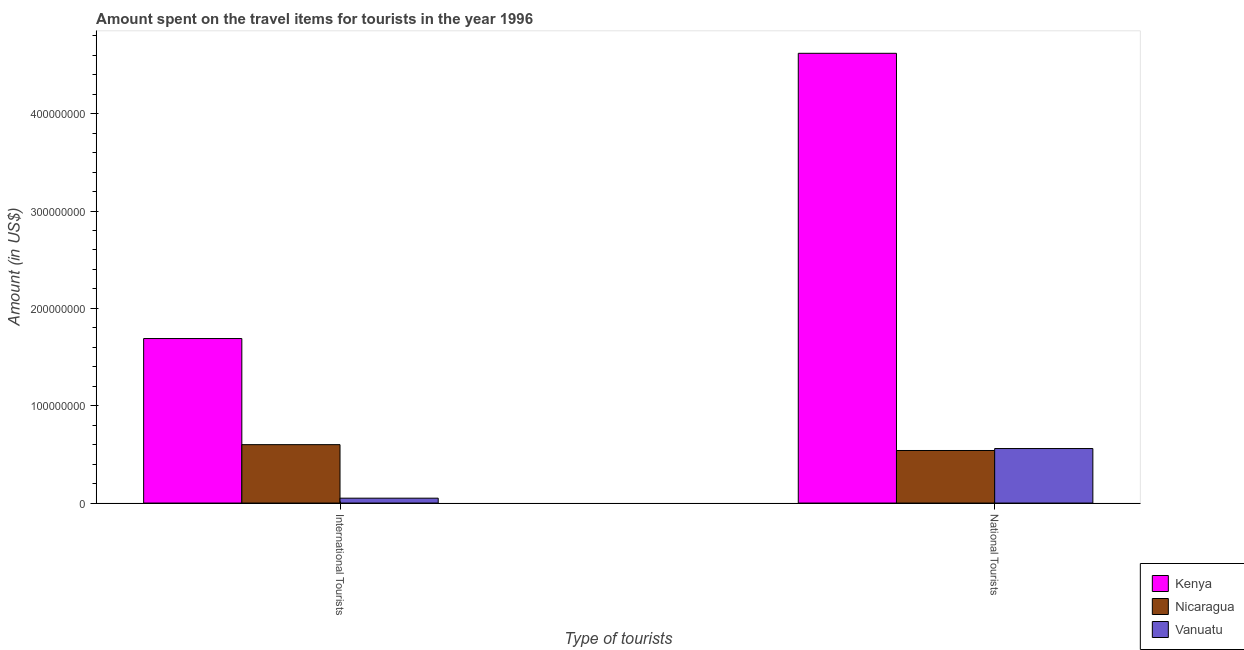How many groups of bars are there?
Your answer should be compact. 2. How many bars are there on the 1st tick from the left?
Keep it short and to the point. 3. What is the label of the 1st group of bars from the left?
Your response must be concise. International Tourists. What is the amount spent on travel items of national tourists in Vanuatu?
Offer a terse response. 5.60e+07. Across all countries, what is the maximum amount spent on travel items of international tourists?
Make the answer very short. 1.69e+08. Across all countries, what is the minimum amount spent on travel items of national tourists?
Offer a terse response. 5.40e+07. In which country was the amount spent on travel items of international tourists maximum?
Keep it short and to the point. Kenya. In which country was the amount spent on travel items of national tourists minimum?
Make the answer very short. Nicaragua. What is the total amount spent on travel items of national tourists in the graph?
Your response must be concise. 5.72e+08. What is the difference between the amount spent on travel items of national tourists in Nicaragua and that in Vanuatu?
Your answer should be compact. -2.00e+06. What is the difference between the amount spent on travel items of international tourists in Vanuatu and the amount spent on travel items of national tourists in Kenya?
Ensure brevity in your answer.  -4.57e+08. What is the average amount spent on travel items of international tourists per country?
Your answer should be very brief. 7.80e+07. What is the difference between the amount spent on travel items of international tourists and amount spent on travel items of national tourists in Vanuatu?
Offer a very short reply. -5.10e+07. What is the ratio of the amount spent on travel items of national tourists in Vanuatu to that in Kenya?
Your response must be concise. 0.12. Is the amount spent on travel items of national tourists in Kenya less than that in Nicaragua?
Your answer should be very brief. No. In how many countries, is the amount spent on travel items of national tourists greater than the average amount spent on travel items of national tourists taken over all countries?
Make the answer very short. 1. What does the 1st bar from the left in National Tourists represents?
Provide a succinct answer. Kenya. What does the 3rd bar from the right in National Tourists represents?
Your answer should be compact. Kenya. How many bars are there?
Your answer should be very brief. 6. What is the difference between two consecutive major ticks on the Y-axis?
Offer a very short reply. 1.00e+08. Does the graph contain any zero values?
Provide a succinct answer. No. What is the title of the graph?
Give a very brief answer. Amount spent on the travel items for tourists in the year 1996. Does "Seychelles" appear as one of the legend labels in the graph?
Offer a very short reply. No. What is the label or title of the X-axis?
Offer a very short reply. Type of tourists. What is the Amount (in US$) in Kenya in International Tourists?
Give a very brief answer. 1.69e+08. What is the Amount (in US$) in Nicaragua in International Tourists?
Your response must be concise. 6.00e+07. What is the Amount (in US$) in Kenya in National Tourists?
Offer a terse response. 4.62e+08. What is the Amount (in US$) of Nicaragua in National Tourists?
Give a very brief answer. 5.40e+07. What is the Amount (in US$) in Vanuatu in National Tourists?
Keep it short and to the point. 5.60e+07. Across all Type of tourists, what is the maximum Amount (in US$) of Kenya?
Give a very brief answer. 4.62e+08. Across all Type of tourists, what is the maximum Amount (in US$) in Nicaragua?
Make the answer very short. 6.00e+07. Across all Type of tourists, what is the maximum Amount (in US$) in Vanuatu?
Give a very brief answer. 5.60e+07. Across all Type of tourists, what is the minimum Amount (in US$) in Kenya?
Your response must be concise. 1.69e+08. Across all Type of tourists, what is the minimum Amount (in US$) in Nicaragua?
Ensure brevity in your answer.  5.40e+07. Across all Type of tourists, what is the minimum Amount (in US$) of Vanuatu?
Your response must be concise. 5.00e+06. What is the total Amount (in US$) in Kenya in the graph?
Give a very brief answer. 6.31e+08. What is the total Amount (in US$) in Nicaragua in the graph?
Ensure brevity in your answer.  1.14e+08. What is the total Amount (in US$) of Vanuatu in the graph?
Offer a terse response. 6.10e+07. What is the difference between the Amount (in US$) in Kenya in International Tourists and that in National Tourists?
Give a very brief answer. -2.93e+08. What is the difference between the Amount (in US$) in Vanuatu in International Tourists and that in National Tourists?
Your response must be concise. -5.10e+07. What is the difference between the Amount (in US$) of Kenya in International Tourists and the Amount (in US$) of Nicaragua in National Tourists?
Make the answer very short. 1.15e+08. What is the difference between the Amount (in US$) of Kenya in International Tourists and the Amount (in US$) of Vanuatu in National Tourists?
Ensure brevity in your answer.  1.13e+08. What is the difference between the Amount (in US$) of Nicaragua in International Tourists and the Amount (in US$) of Vanuatu in National Tourists?
Keep it short and to the point. 4.00e+06. What is the average Amount (in US$) of Kenya per Type of tourists?
Offer a very short reply. 3.16e+08. What is the average Amount (in US$) of Nicaragua per Type of tourists?
Offer a terse response. 5.70e+07. What is the average Amount (in US$) of Vanuatu per Type of tourists?
Offer a terse response. 3.05e+07. What is the difference between the Amount (in US$) in Kenya and Amount (in US$) in Nicaragua in International Tourists?
Your response must be concise. 1.09e+08. What is the difference between the Amount (in US$) in Kenya and Amount (in US$) in Vanuatu in International Tourists?
Provide a succinct answer. 1.64e+08. What is the difference between the Amount (in US$) of Nicaragua and Amount (in US$) of Vanuatu in International Tourists?
Your answer should be compact. 5.50e+07. What is the difference between the Amount (in US$) of Kenya and Amount (in US$) of Nicaragua in National Tourists?
Keep it short and to the point. 4.08e+08. What is the difference between the Amount (in US$) in Kenya and Amount (in US$) in Vanuatu in National Tourists?
Ensure brevity in your answer.  4.06e+08. What is the difference between the Amount (in US$) of Nicaragua and Amount (in US$) of Vanuatu in National Tourists?
Your answer should be very brief. -2.00e+06. What is the ratio of the Amount (in US$) in Kenya in International Tourists to that in National Tourists?
Ensure brevity in your answer.  0.37. What is the ratio of the Amount (in US$) of Nicaragua in International Tourists to that in National Tourists?
Your answer should be compact. 1.11. What is the ratio of the Amount (in US$) of Vanuatu in International Tourists to that in National Tourists?
Provide a succinct answer. 0.09. What is the difference between the highest and the second highest Amount (in US$) of Kenya?
Give a very brief answer. 2.93e+08. What is the difference between the highest and the second highest Amount (in US$) in Nicaragua?
Offer a very short reply. 6.00e+06. What is the difference between the highest and the second highest Amount (in US$) in Vanuatu?
Ensure brevity in your answer.  5.10e+07. What is the difference between the highest and the lowest Amount (in US$) of Kenya?
Ensure brevity in your answer.  2.93e+08. What is the difference between the highest and the lowest Amount (in US$) in Vanuatu?
Offer a very short reply. 5.10e+07. 